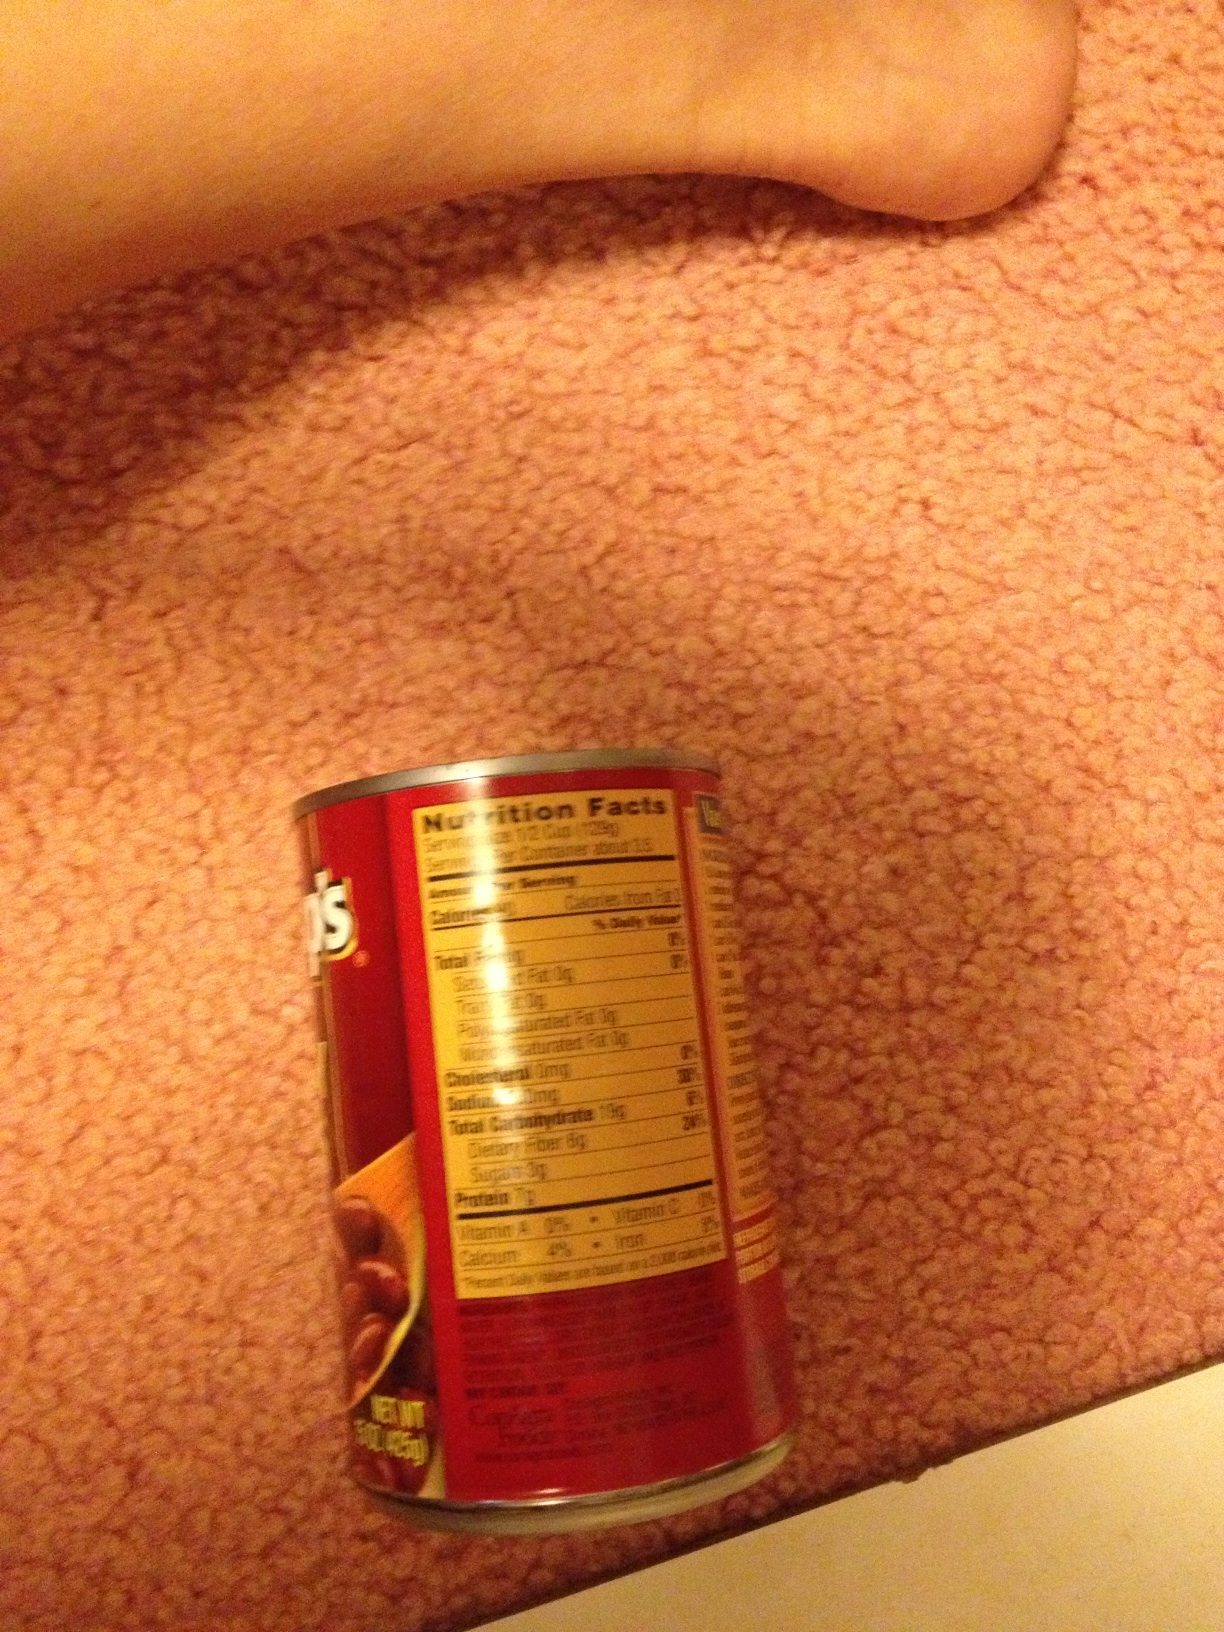What brand of beans is this? The brand appears to be visible in the label, but due to the partial visibility and angle of the image, it's difficult to read the brand name clearly. Can you tell what the nutritional information says? The nutritional label shows details like calories, total fat, cholesterol, sodium, total carbohydrates, and protein per serving. This is helpful for those monitoring their dietary intake. What can you infer about the environment the can is in? The can is placed on a carpet with a human foot visible in the frame. This suggests that the can might be in a domestic environment, possibly near a kitchen or dining area. 